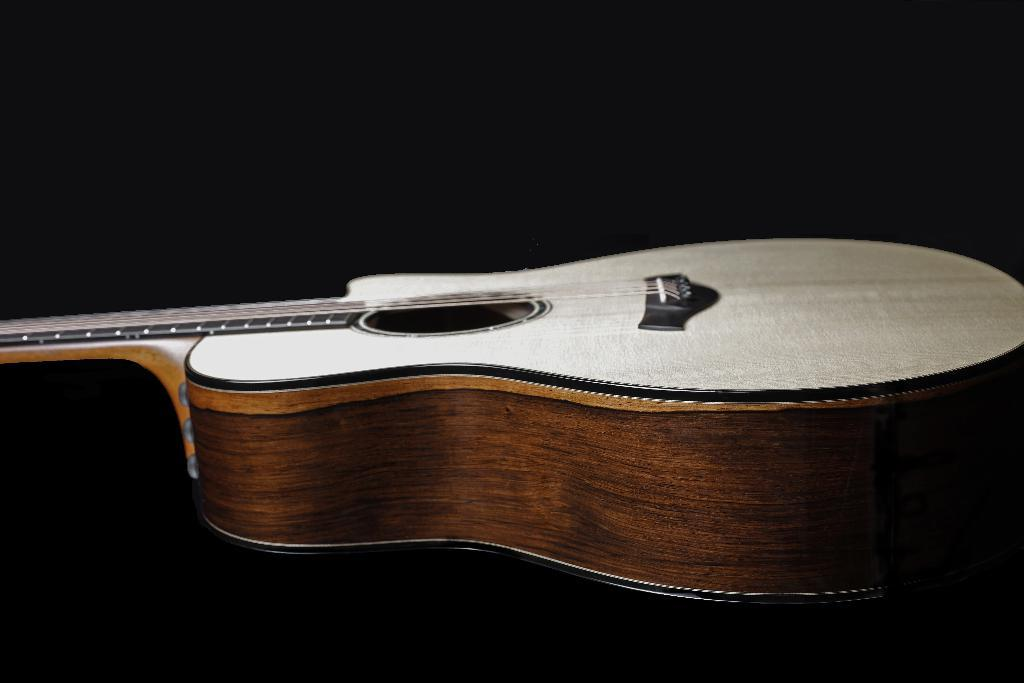What musical instrument is present in the image? There is a guitar in the picture. What colors can be seen on the guitar? The guitar is white and brown in color. How would you describe the background of the image? The background of the image is dark. Can you see any glue on the guitar strings in the image? There is no glue present on the guitar strings in the image. Are there any cows visible in the background of the image? There are no cows present in the image; the background is dark. 